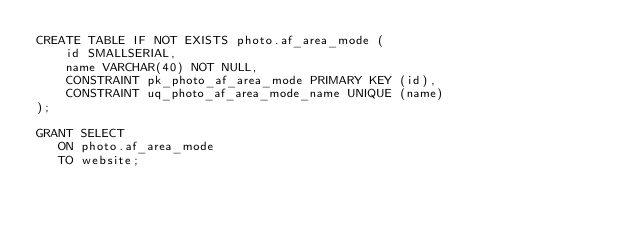Convert code to text. <code><loc_0><loc_0><loc_500><loc_500><_SQL_>CREATE TABLE IF NOT EXISTS photo.af_area_mode (
    id SMALLSERIAL,
    name VARCHAR(40) NOT NULL,
    CONSTRAINT pk_photo_af_area_mode PRIMARY KEY (id),
    CONSTRAINT uq_photo_af_area_mode_name UNIQUE (name)
);

GRANT SELECT
   ON photo.af_area_mode
   TO website;
</code> 